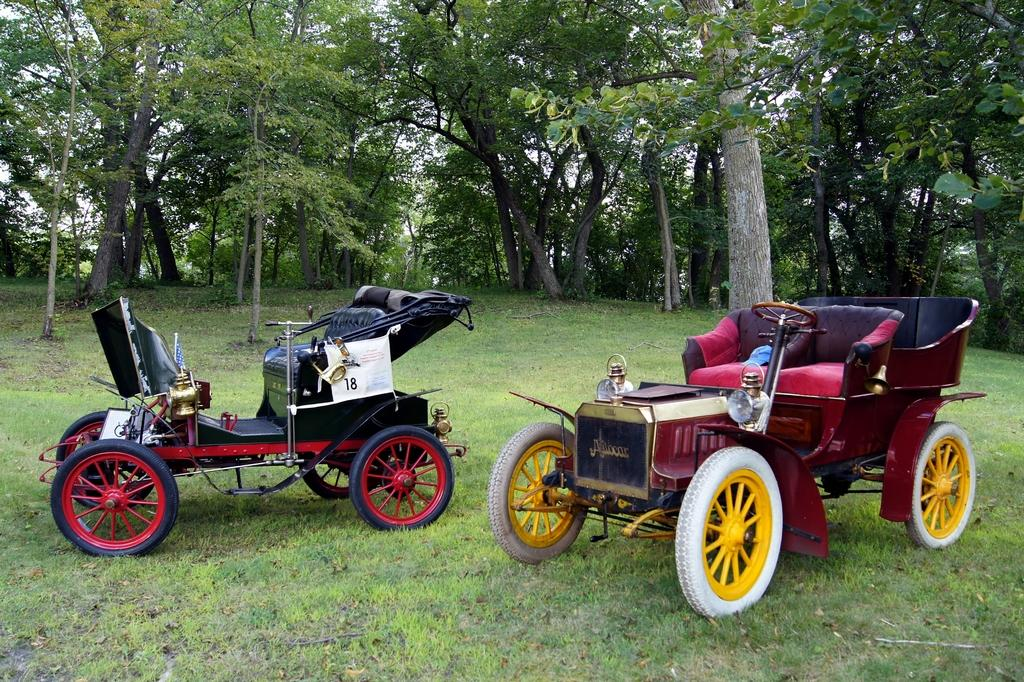How many vehicles can be seen in the image? There are two vehicles in the image. Where are the vehicles located? The vehicles are on the ground. What type of surface is visible beneath the vehicles? There is grass visible on the ground. What can be seen in the background of the image? There are trees in the background of the image. What type of airport is visible in the image? There is no airport present in the image. What is the interest of the carpenter in the image? There is no carpenter present in the image. 